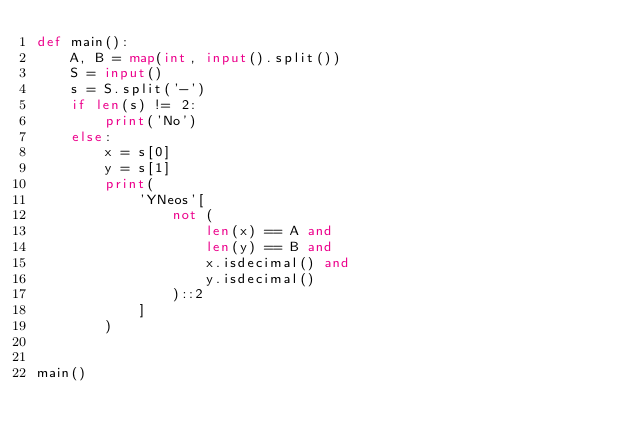Convert code to text. <code><loc_0><loc_0><loc_500><loc_500><_Python_>def main():
    A, B = map(int, input().split())
    S = input()
    s = S.split('-')
    if len(s) != 2:
        print('No')
    else:
        x = s[0]
        y = s[1]
        print(
            'YNeos'[
                not (
                    len(x) == A and
                    len(y) == B and
                    x.isdecimal() and
                    y.isdecimal()
                )::2
            ]
        )


main()
</code> 